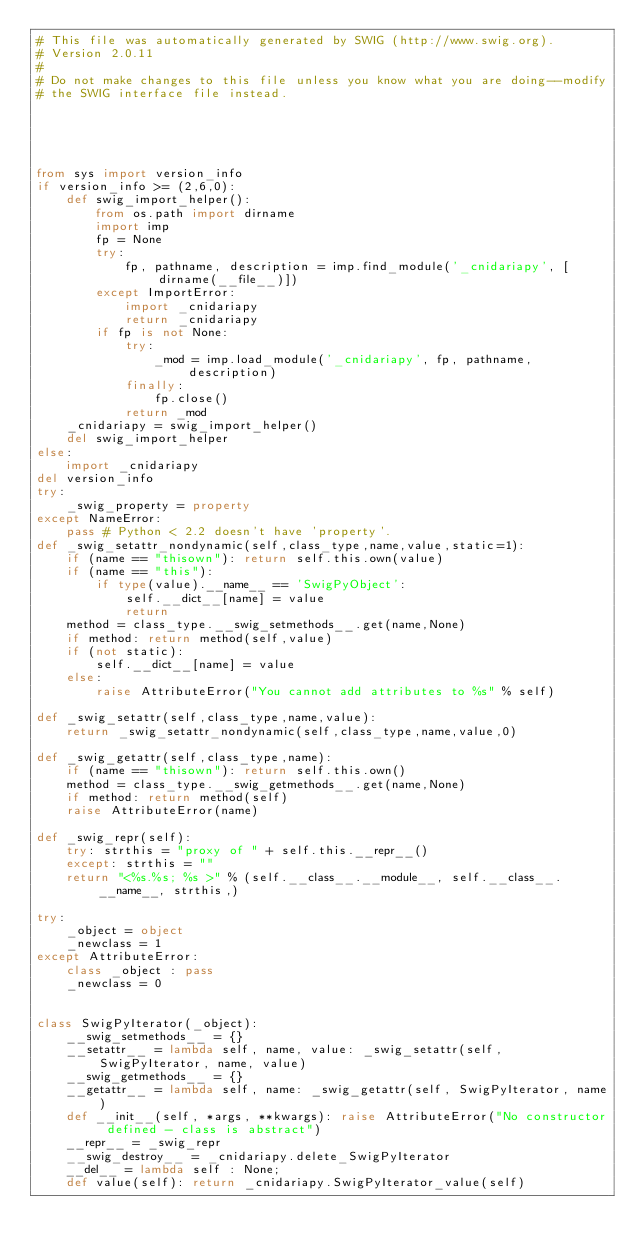<code> <loc_0><loc_0><loc_500><loc_500><_Python_># This file was automatically generated by SWIG (http://www.swig.org).
# Version 2.0.11
#
# Do not make changes to this file unless you know what you are doing--modify
# the SWIG interface file instead.





from sys import version_info
if version_info >= (2,6,0):
    def swig_import_helper():
        from os.path import dirname
        import imp
        fp = None
        try:
            fp, pathname, description = imp.find_module('_cnidariapy', [dirname(__file__)])
        except ImportError:
            import _cnidariapy
            return _cnidariapy
        if fp is not None:
            try:
                _mod = imp.load_module('_cnidariapy', fp, pathname, description)
            finally:
                fp.close()
            return _mod
    _cnidariapy = swig_import_helper()
    del swig_import_helper
else:
    import _cnidariapy
del version_info
try:
    _swig_property = property
except NameError:
    pass # Python < 2.2 doesn't have 'property'.
def _swig_setattr_nondynamic(self,class_type,name,value,static=1):
    if (name == "thisown"): return self.this.own(value)
    if (name == "this"):
        if type(value).__name__ == 'SwigPyObject':
            self.__dict__[name] = value
            return
    method = class_type.__swig_setmethods__.get(name,None)
    if method: return method(self,value)
    if (not static):
        self.__dict__[name] = value
    else:
        raise AttributeError("You cannot add attributes to %s" % self)

def _swig_setattr(self,class_type,name,value):
    return _swig_setattr_nondynamic(self,class_type,name,value,0)

def _swig_getattr(self,class_type,name):
    if (name == "thisown"): return self.this.own()
    method = class_type.__swig_getmethods__.get(name,None)
    if method: return method(self)
    raise AttributeError(name)

def _swig_repr(self):
    try: strthis = "proxy of " + self.this.__repr__()
    except: strthis = ""
    return "<%s.%s; %s >" % (self.__class__.__module__, self.__class__.__name__, strthis,)

try:
    _object = object
    _newclass = 1
except AttributeError:
    class _object : pass
    _newclass = 0


class SwigPyIterator(_object):
    __swig_setmethods__ = {}
    __setattr__ = lambda self, name, value: _swig_setattr(self, SwigPyIterator, name, value)
    __swig_getmethods__ = {}
    __getattr__ = lambda self, name: _swig_getattr(self, SwigPyIterator, name)
    def __init__(self, *args, **kwargs): raise AttributeError("No constructor defined - class is abstract")
    __repr__ = _swig_repr
    __swig_destroy__ = _cnidariapy.delete_SwigPyIterator
    __del__ = lambda self : None;
    def value(self): return _cnidariapy.SwigPyIterator_value(self)</code> 